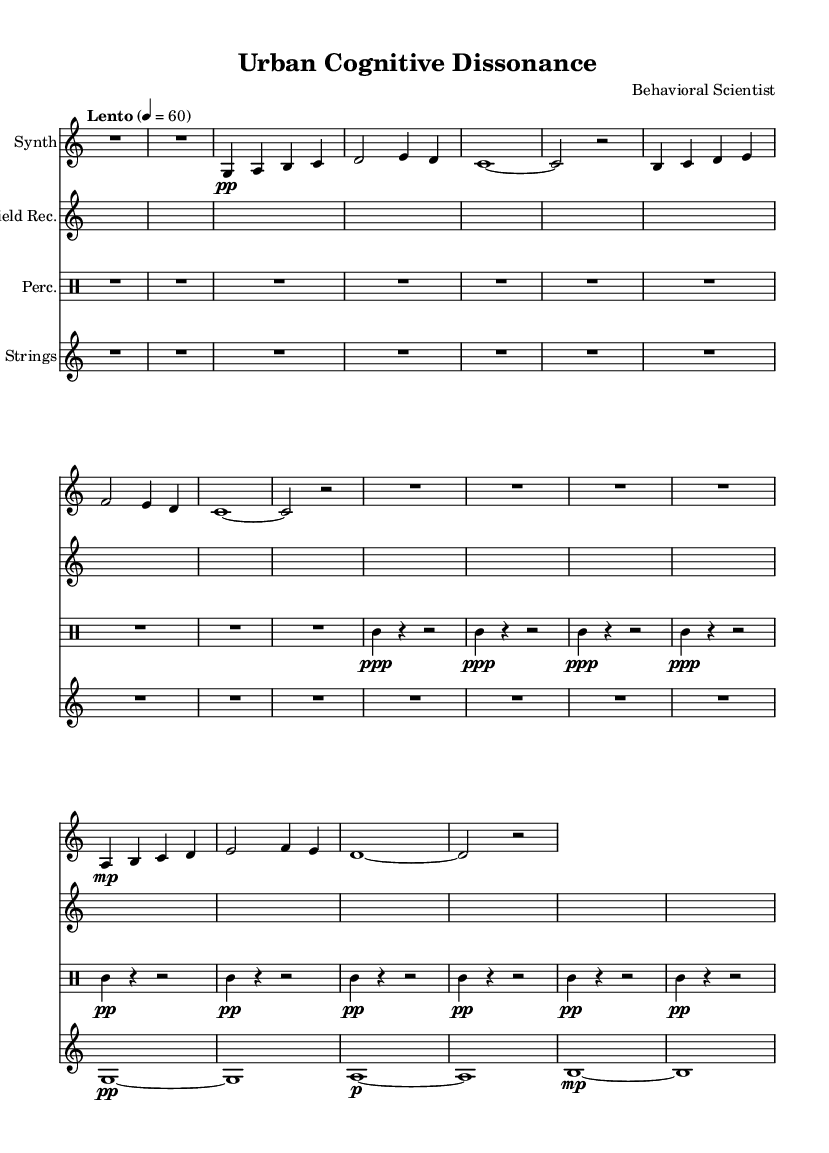What is the title of this piece? The title is prominently displayed at the beginning of the sheet music under the header section and reads "Urban Cognitive Dissonance."
Answer: Urban Cognitive Dissonance What is the tempo marking for this music? The tempo marking is indicated at the beginning of the piece, stating "Lento" with a metronome marking of 60 beats per minute.
Answer: Lento 60 What is the time signature of the piece? The time signature is found in the global settings of the music and is indicated as 4/4.
Answer: 4/4 How many measures are there in the synthesizer part? The synthesizer part consists of 12 measures as indicated by the rhythmic groupings and rests.
Answer: 12 What instruments are used in this composition? The instruments are listed in the score with their respective labels: Synth, Field Rec. (Field Recordings), Perc. (Percussion), and Strings.
Answer: Synth, Field Rec., Perc., Strings What dynamics are indicated for the strings at the beginning? The dynamics for the strings are marked as "pp" for soft and then contrasted with a "p" marking later in the part.
Answer: pp Why are there longer rests in the synthesizer part compared to the percussion? The longer rests in the synthesizer part suggest a more atmospheric effect, allowing for space and reflection in contrast to the more rhythmic and sustained nature of percussion.
Answer: Atmospheric effect 